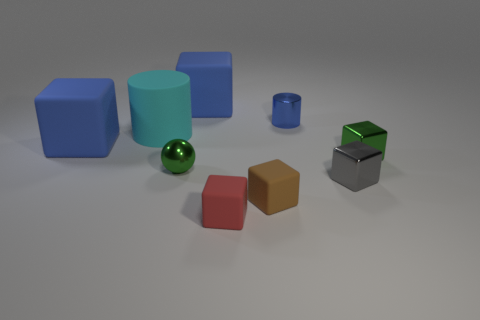Subtract 1 blocks. How many blocks are left? 5 Subtract all red cubes. How many cubes are left? 5 Subtract all red blocks. How many blocks are left? 5 Subtract all green blocks. Subtract all green cylinders. How many blocks are left? 5 Add 1 tiny gray cylinders. How many objects exist? 10 Subtract all cylinders. How many objects are left? 7 Subtract 0 gray spheres. How many objects are left? 9 Subtract all small blue things. Subtract all tiny green metallic objects. How many objects are left? 6 Add 2 red rubber blocks. How many red rubber blocks are left? 3 Add 6 tiny blue metallic cylinders. How many tiny blue metallic cylinders exist? 7 